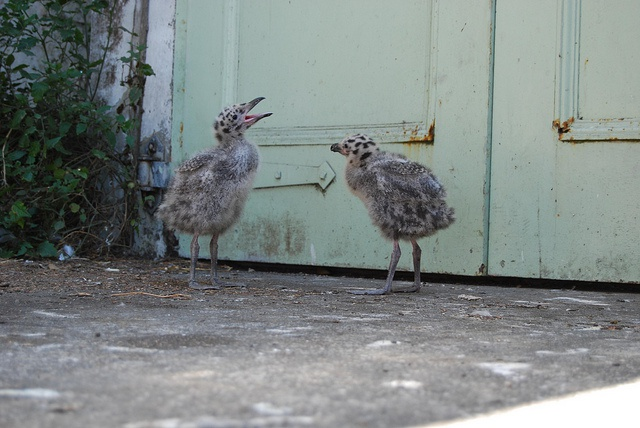Describe the objects in this image and their specific colors. I can see bird in gray, darkgray, and black tones and bird in gray and black tones in this image. 